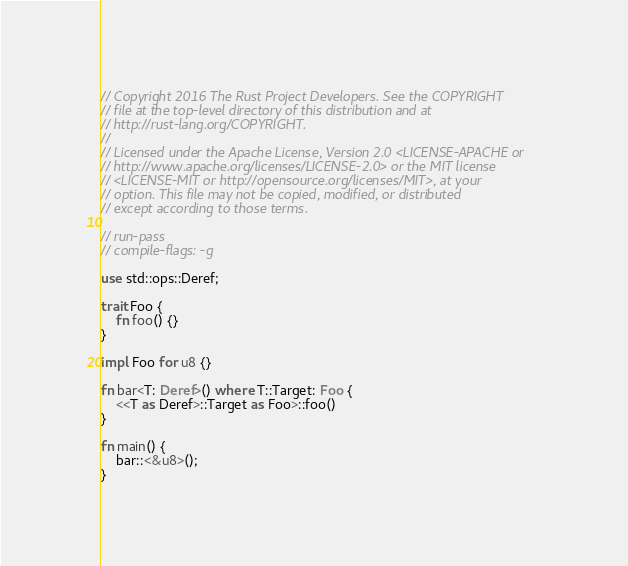Convert code to text. <code><loc_0><loc_0><loc_500><loc_500><_Rust_>// Copyright 2016 The Rust Project Developers. See the COPYRIGHT
// file at the top-level directory of this distribution and at
// http://rust-lang.org/COPYRIGHT.
//
// Licensed under the Apache License, Version 2.0 <LICENSE-APACHE or
// http://www.apache.org/licenses/LICENSE-2.0> or the MIT license
// <LICENSE-MIT or http://opensource.org/licenses/MIT>, at your
// option. This file may not be copied, modified, or distributed
// except according to those terms.

// run-pass
// compile-flags: -g

use std::ops::Deref;

trait Foo {
    fn foo() {}
}

impl Foo for u8 {}

fn bar<T: Deref>() where T::Target: Foo {
    <<T as Deref>::Target as Foo>::foo()
}

fn main() {
    bar::<&u8>();
}
</code> 